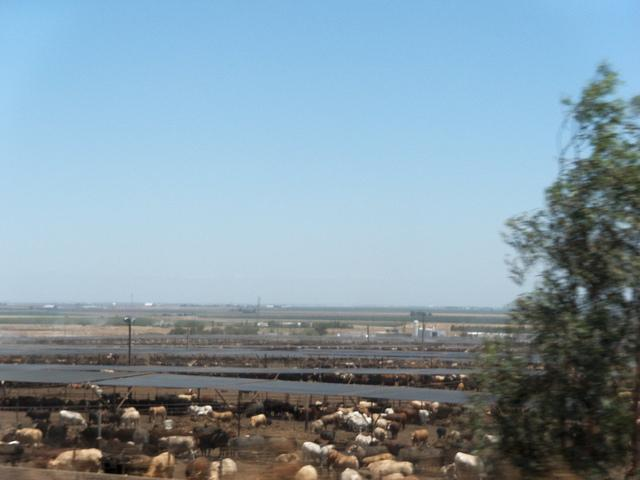What danger does the fence at the back of the lot protect the cows from? Please explain your reasoning. drowning. A large area has water in the background. 